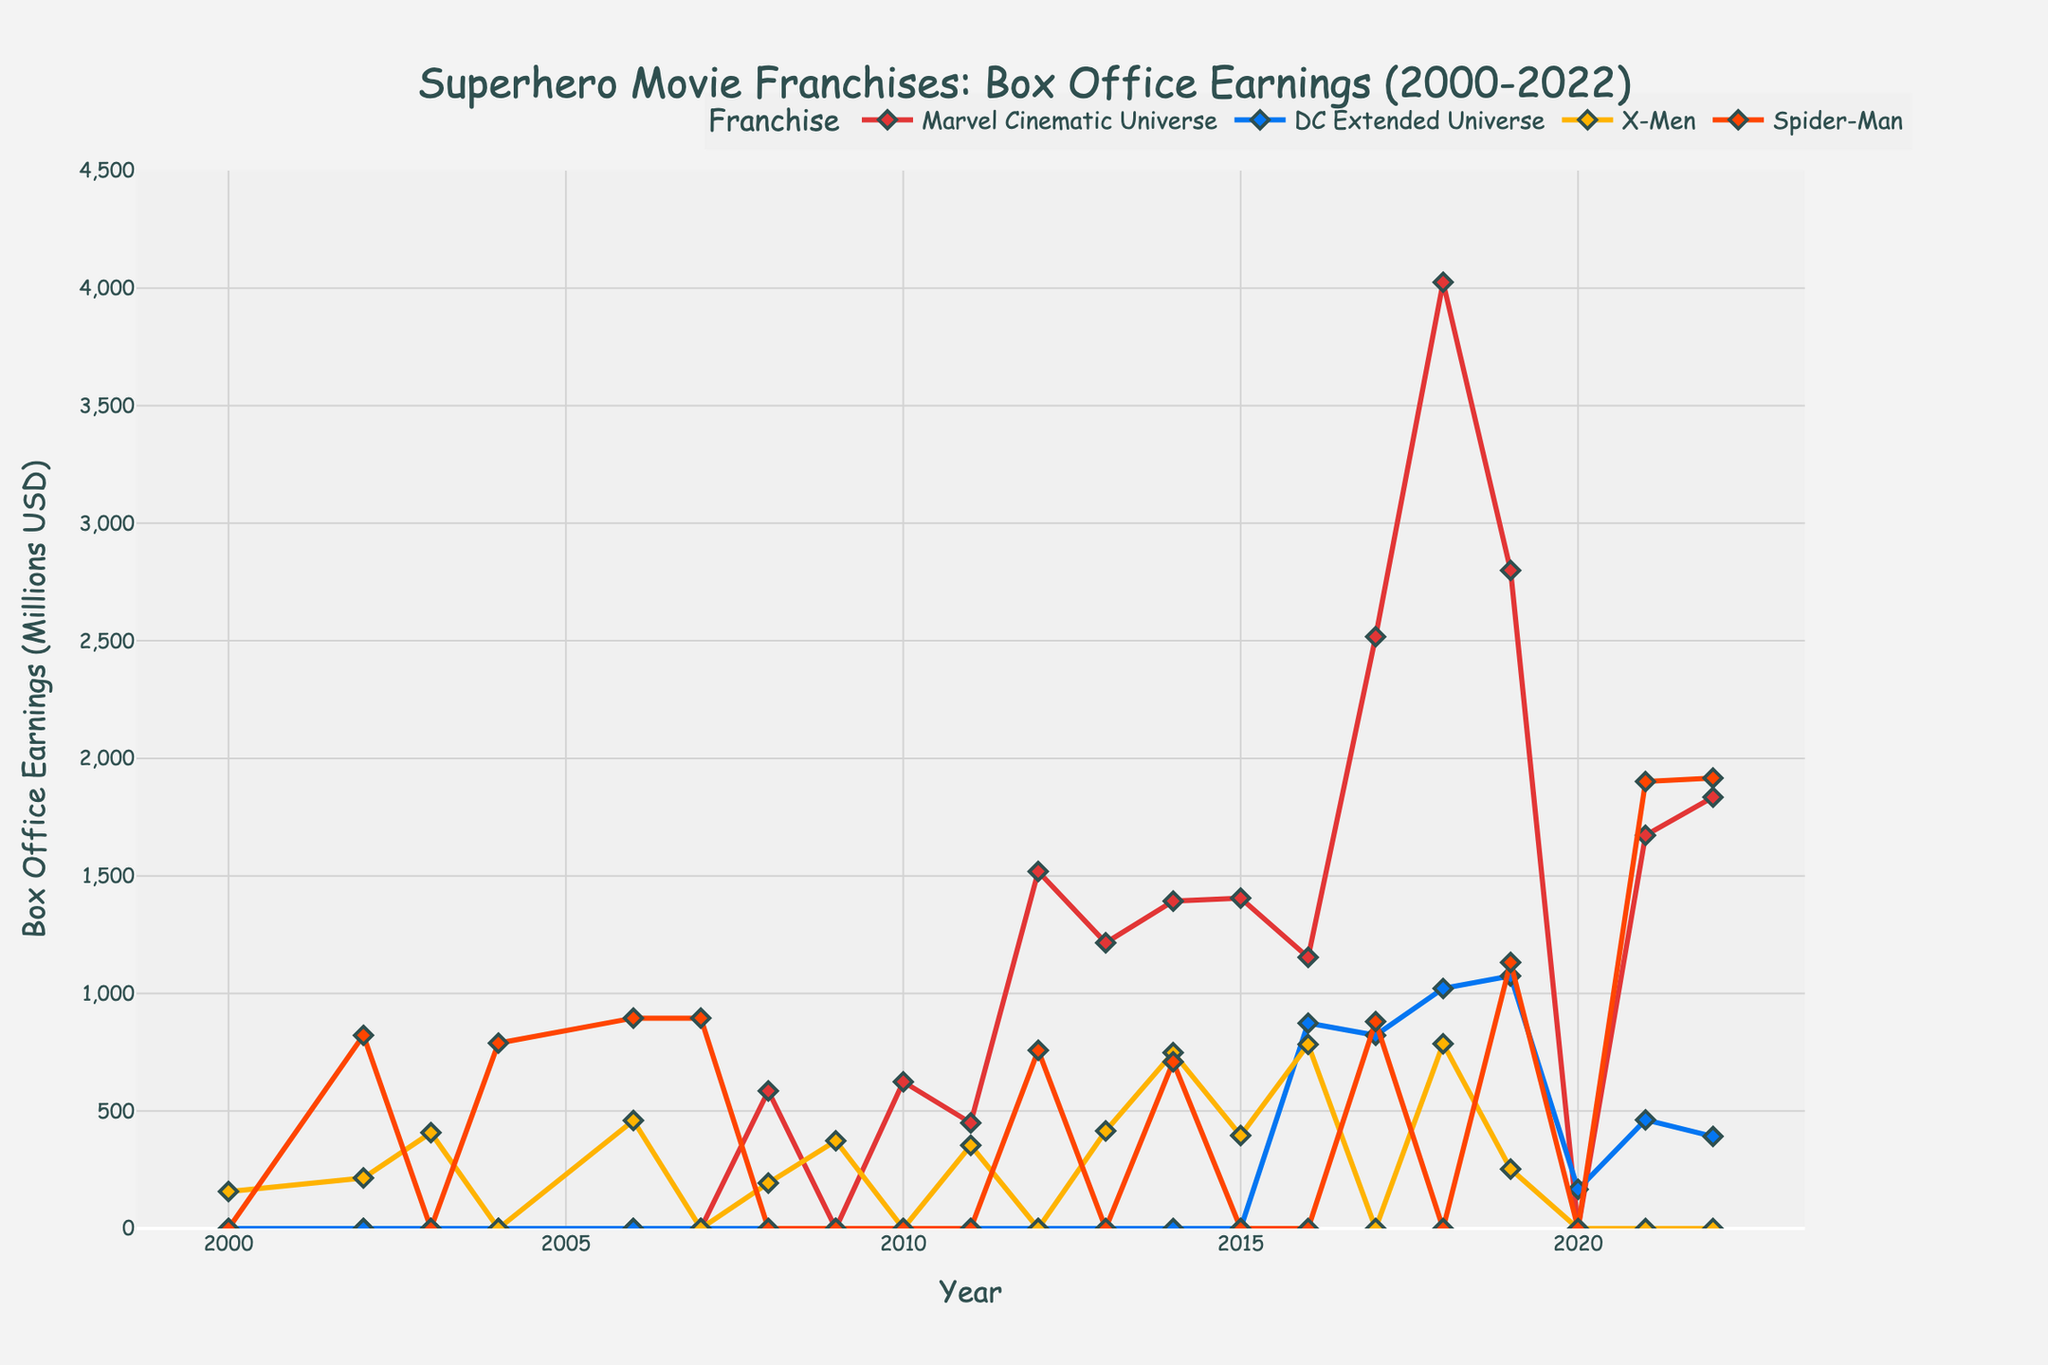what year did the Marvel Cinematic Universe (MCU) first surpass $1 billion in box office earnings? From the chart, it's clear that the MCU earnings surpass $1 billion in 2012, as the point for that year reaches approximately $1.5 billion, which is the first instance.
Answer: 2012 which franchise had the highest box office earnings in 2019? By observing the data points for 2019 on the chart, the highest marker belongs to the Marvel Cinematic Universe (MCU) with approximately $2.8 billion in box office earnings.
Answer: Marvel Cinematic Universe what was the combined box office earnings of the X-Men franchise in 2000 and 2019? For 2000, the X-Men's earnings were $157.3 million. For 2019, it was $252.9 million. Adding these two values gives us 157.3 + 252.9 = 410.2 million USD.
Answer: 410.2 million USD between Spider-Man and DC Extended Universe (DCEU), which had greater box office earnings in 2021 and by how much? Checking the points for 2021, Spider-Man earned approximately $1901.2 million, while DCEU earned about $462.2 million. The difference is 1901.2 - 462.2 = 1439 million USD.
Answer: Spider-Man by 1439 million USD between 2002 and 2004, which franchise showed a notable increase in box office earnings and by how much? From 2002 to 2004, the Spider-Man franchise soared from approximately $821.7 million in 2002 to $788.6 million in 2004. Conversely, the X-Men franchise declined during this time. The notable increase for Spider-Man is 788.6 - 0 (for 2003) = 788.6 million USD, but it's less than the change from 0 to 214.9. For the MCU and DCEU, there were no earnings in that period.
Answer: Spider-Man by 214.9 million USD in which years did the X-Men franchise have zero box office earnings? Observing the line representing the X-Men franchise, it's clear that for certain years, it lies on the x-axis. These years are 2004, 2010, 2012, 2020, 2021, and 2022.
Answer: 2004, 2010, 2012, 2020, 2021, 2022 in 2016 and 2018, which franchise had a higher box office earnings, Spider-Man or X-Men, and by how much in each year? In 2016, Spider-Man had $0, and X-Men had $783.1 million, so X-Men is higher by 783.1 million. In 2018, Spider-Man had $0, and X-Men had $785.9 million, so X-Men is higher by 785.9 million.
Answer: X-Men by 783.1 million in 2016 and by 785.9 million in 2018 which franchise had the lowest earnings in 2022? Observing the points for 2022, the lowest data point belongs to the DC Extended Universe with approximately $391.7 million.
Answer: DC Extended Universe what year did all four franchises have a non-zero box office earnings, and what were the total earnings for that year? According to the chart, the year 2016 is the only one where Marvel Cinematic Universe ($1153.3 million), DC Extended Universe ($873.6 million), X-Men ($783.1 million), and Spider-Man ($0 million). Adding up their earnings: 1153.3 + 873.6 + 783.1 + 0 = 2810 million USD.
Answer: 2016; 2810 million USD what was the trend of box office earnings for the Marvel Cinematic Universe from 2008 to 2022? Observing the MCU line from 2008 to 2022, the earnings increased sharply from 585.2 million in 2008, peaking around 2018 with 4025.1 million, followed by a slight dip in 2019 to 2799.5 million, another dip in 2020 due to COVID-19, then recovering again in 2021 and 2022 with 1672.6 million and 1834.8 million respectively.
Answer: An upward trend with peaks and slight dips 